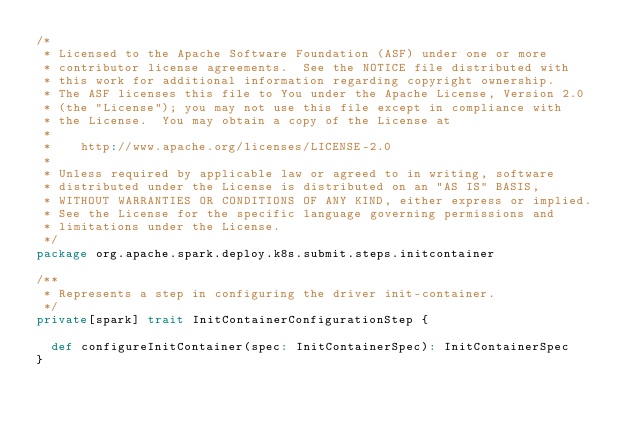Convert code to text. <code><loc_0><loc_0><loc_500><loc_500><_Scala_>/*
 * Licensed to the Apache Software Foundation (ASF) under one or more
 * contributor license agreements.  See the NOTICE file distributed with
 * this work for additional information regarding copyright ownership.
 * The ASF licenses this file to You under the Apache License, Version 2.0
 * (the "License"); you may not use this file except in compliance with
 * the License.  You may obtain a copy of the License at
 *
 *    http://www.apache.org/licenses/LICENSE-2.0
 *
 * Unless required by applicable law or agreed to in writing, software
 * distributed under the License is distributed on an "AS IS" BASIS,
 * WITHOUT WARRANTIES OR CONDITIONS OF ANY KIND, either express or implied.
 * See the License for the specific language governing permissions and
 * limitations under the License.
 */
package org.apache.spark.deploy.k8s.submit.steps.initcontainer

/**
 * Represents a step in configuring the driver init-container.
 */
private[spark] trait InitContainerConfigurationStep {

  def configureInitContainer(spec: InitContainerSpec): InitContainerSpec
}
</code> 